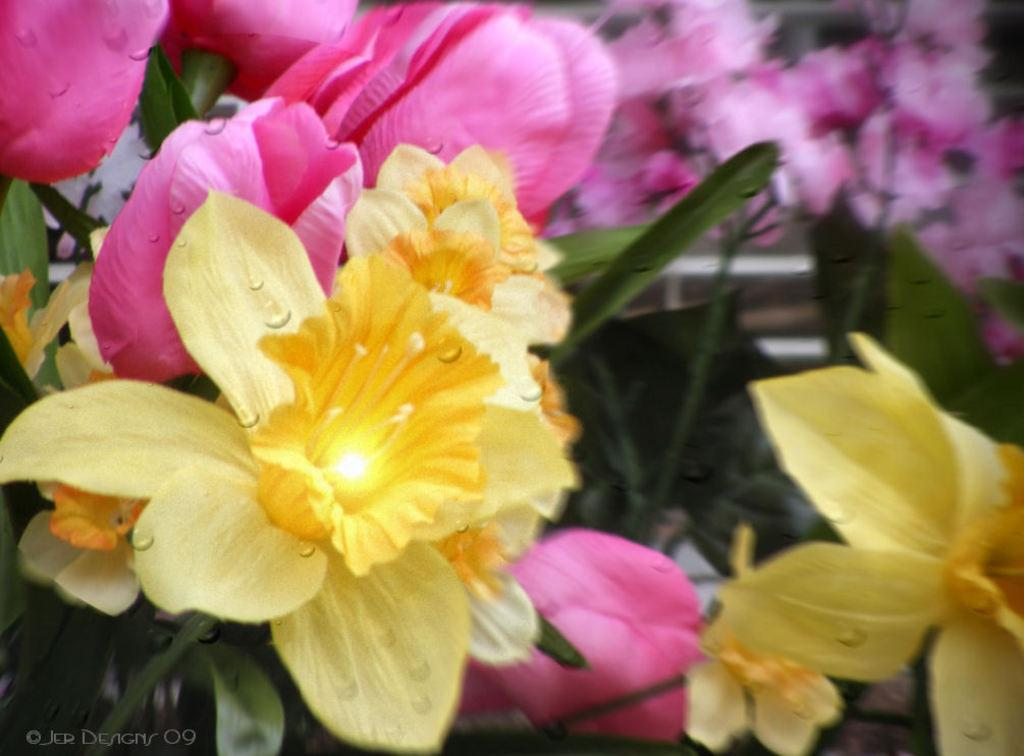What type of plants are in the image? There are flowers in the image. What colors are the flowers? The flowers are in yellow and pink colors. What part of the flowers is green in the image? There are green leaves at the bottom of the image. What type of yam is being used for the baseball discussion in the image? There is no yam or baseball discussion present in the image; it features flowers and green leaves. 